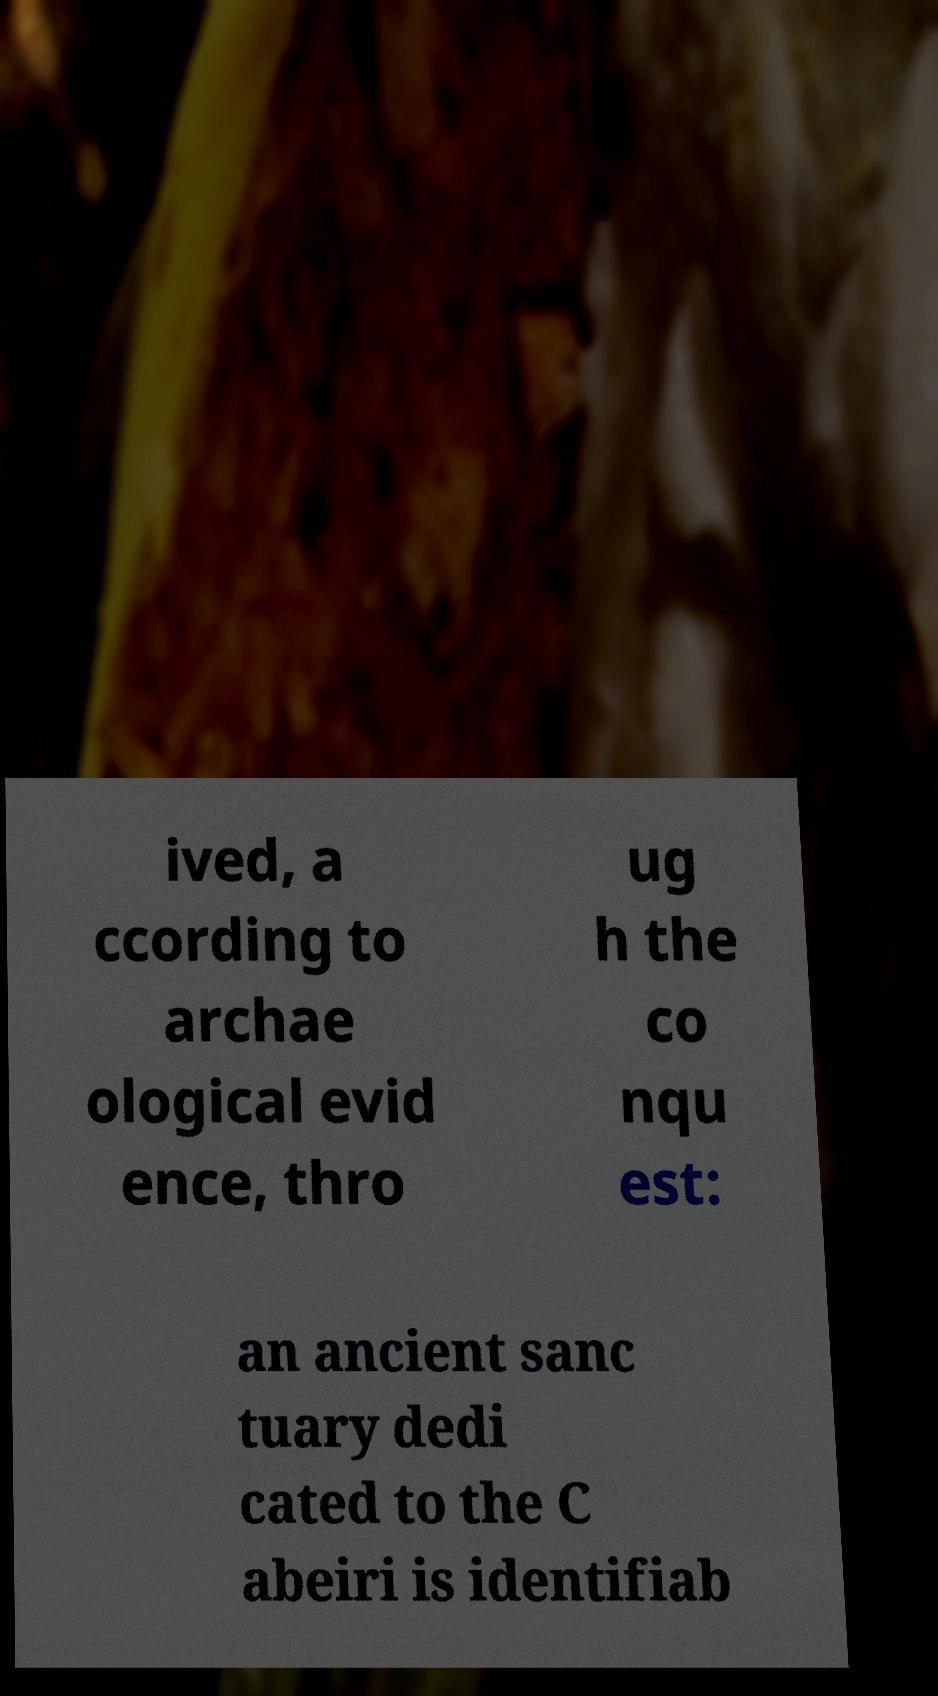What messages or text are displayed in this image? I need them in a readable, typed format. ived, a ccording to archae ological evid ence, thro ug h the co nqu est: an ancient sanc tuary dedi cated to the C abeiri is identifiab 